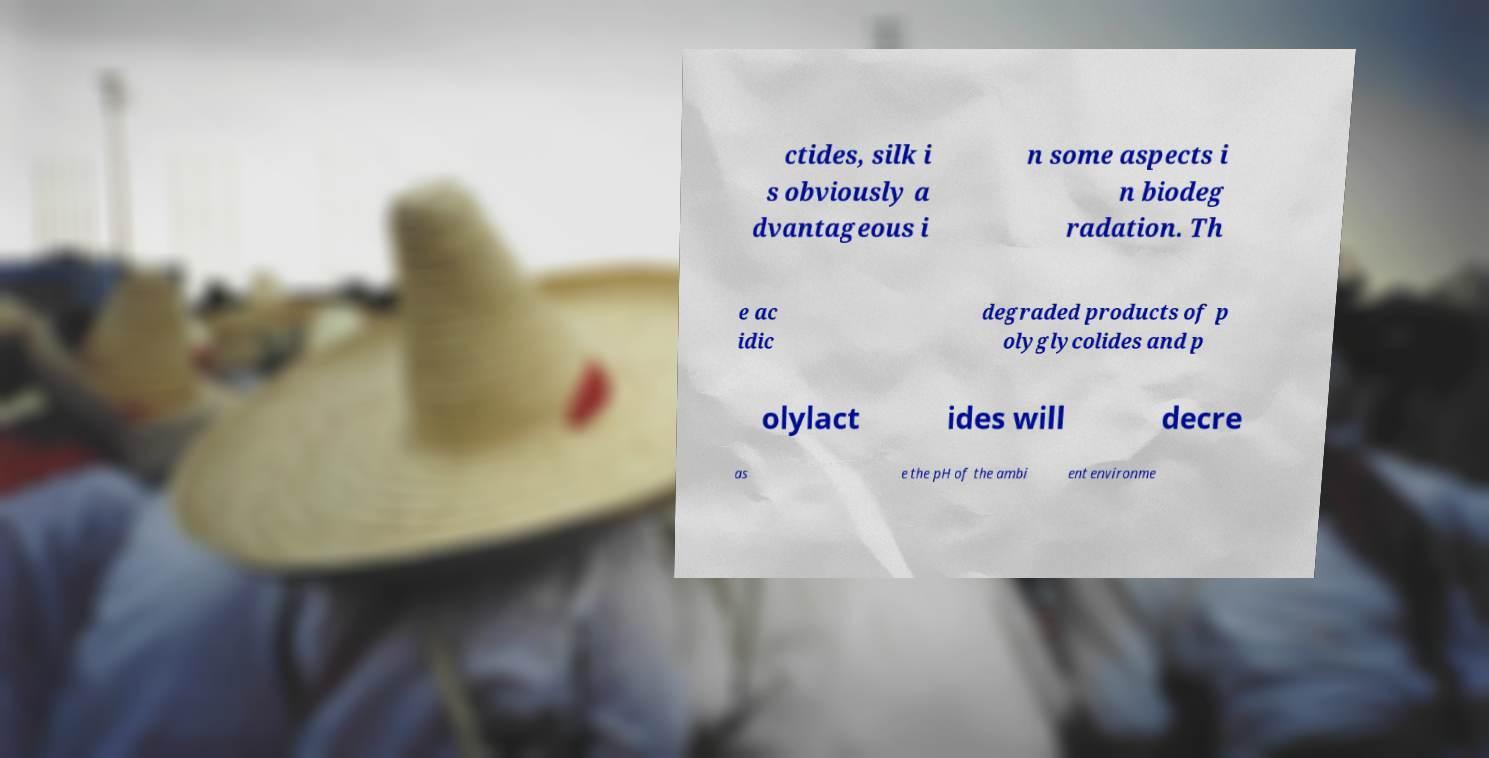What messages or text are displayed in this image? I need them in a readable, typed format. ctides, silk i s obviously a dvantageous i n some aspects i n biodeg radation. Th e ac idic degraded products of p olyglycolides and p olylact ides will decre as e the pH of the ambi ent environme 